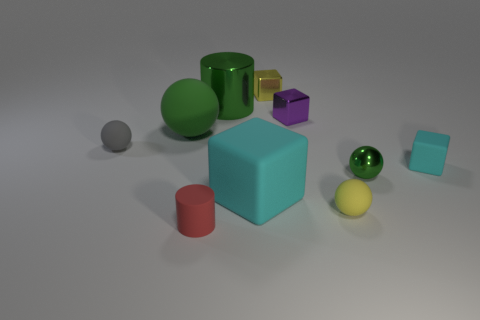Subtract all cylinders. How many objects are left? 8 Add 4 yellow matte spheres. How many yellow matte spheres exist? 5 Subtract 0 blue cubes. How many objects are left? 10 Subtract all tiny cyan blocks. Subtract all big balls. How many objects are left? 8 Add 8 tiny yellow spheres. How many tiny yellow spheres are left? 9 